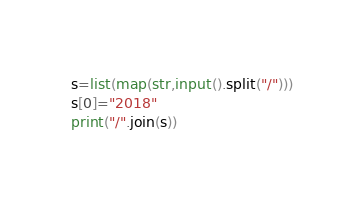<code> <loc_0><loc_0><loc_500><loc_500><_Python_>s=list(map(str,input().split("/")))
s[0]="2018"
print("/".join(s))</code> 